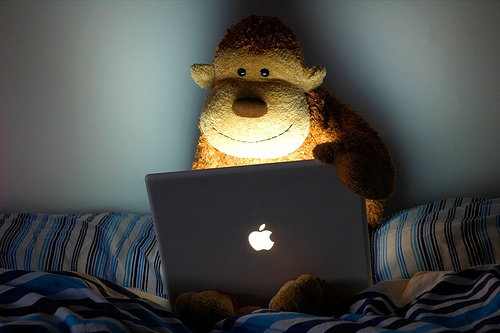<image>
Is there a bear in the laptop? No. The bear is not contained within the laptop. These objects have a different spatial relationship. 